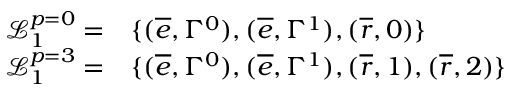<formula> <loc_0><loc_0><loc_500><loc_500>\begin{array} { r l } { \mathcal { L } _ { 1 } ^ { p = 0 } = } & { \{ ( \overline { e } , \Gamma ^ { 0 } ) , ( \overline { e } , \Gamma ^ { 1 } ) , ( \overline { r } , 0 ) \} } \\ { \mathcal { L } _ { 1 } ^ { p = 3 } = } & { \{ ( \overline { e } , \Gamma ^ { 0 } ) , ( \overline { e } , \Gamma ^ { 1 } ) , ( \overline { r } , 1 ) , ( \overline { r } , 2 ) \} } \end{array}</formula> 